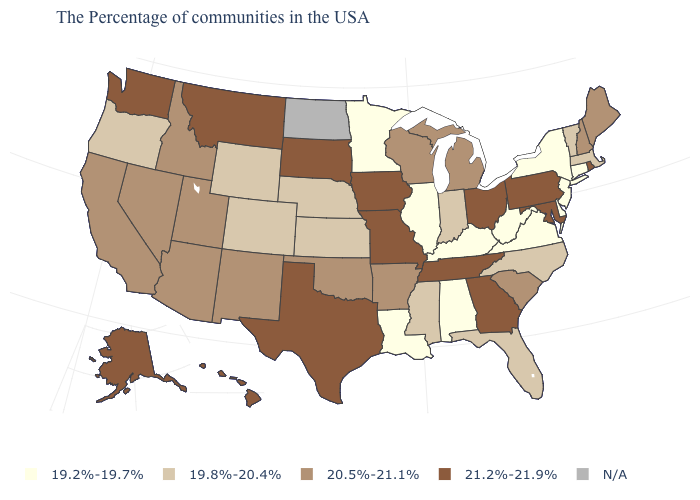Does Delaware have the highest value in the USA?
Concise answer only. No. What is the value of Montana?
Be succinct. 21.2%-21.9%. Is the legend a continuous bar?
Concise answer only. No. What is the value of South Dakota?
Concise answer only. 21.2%-21.9%. Name the states that have a value in the range 20.5%-21.1%?
Be succinct. Maine, New Hampshire, South Carolina, Michigan, Wisconsin, Arkansas, Oklahoma, New Mexico, Utah, Arizona, Idaho, Nevada, California. What is the value of Rhode Island?
Concise answer only. 21.2%-21.9%. What is the value of Illinois?
Give a very brief answer. 19.2%-19.7%. Does Alabama have the lowest value in the USA?
Quick response, please. Yes. Name the states that have a value in the range 21.2%-21.9%?
Keep it brief. Rhode Island, Maryland, Pennsylvania, Ohio, Georgia, Tennessee, Missouri, Iowa, Texas, South Dakota, Montana, Washington, Alaska, Hawaii. Name the states that have a value in the range 19.2%-19.7%?
Give a very brief answer. Connecticut, New York, New Jersey, Delaware, Virginia, West Virginia, Kentucky, Alabama, Illinois, Louisiana, Minnesota. What is the lowest value in states that border Michigan?
Be succinct. 19.8%-20.4%. What is the highest value in the West ?
Keep it brief. 21.2%-21.9%. Among the states that border North Carolina , which have the lowest value?
Give a very brief answer. Virginia. What is the lowest value in the West?
Short answer required. 19.8%-20.4%. 